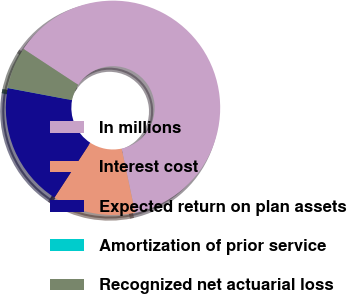Convert chart. <chart><loc_0><loc_0><loc_500><loc_500><pie_chart><fcel>In millions<fcel>Interest cost<fcel>Expected return on plan assets<fcel>Amortization of prior service<fcel>Recognized net actuarial loss<nl><fcel>62.43%<fcel>12.51%<fcel>18.75%<fcel>0.03%<fcel>6.27%<nl></chart> 